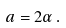Convert formula to latex. <formula><loc_0><loc_0><loc_500><loc_500>a = 2 \alpha \, .</formula> 